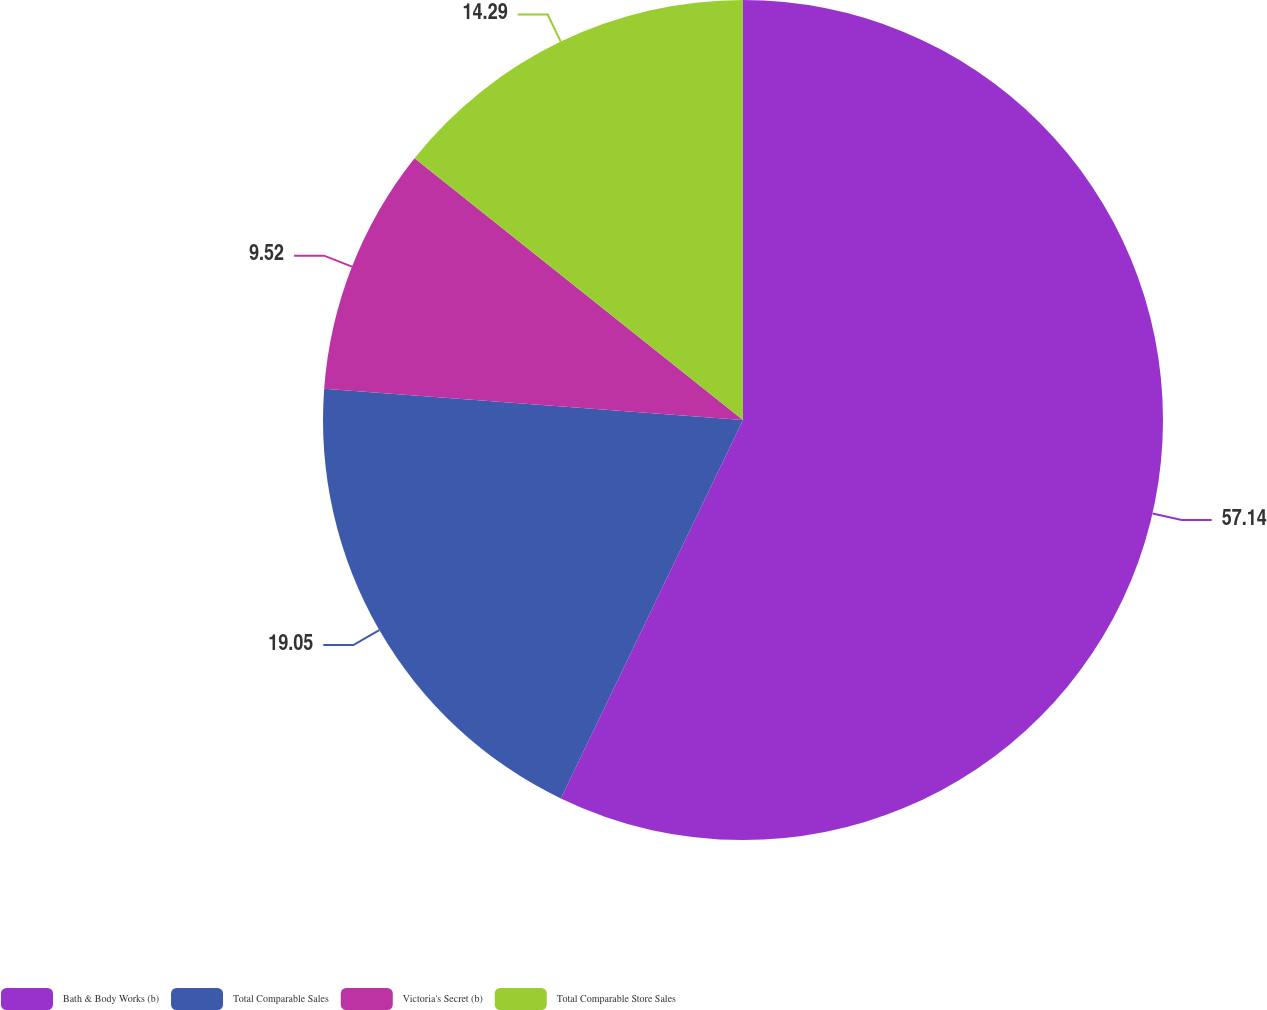Convert chart to OTSL. <chart><loc_0><loc_0><loc_500><loc_500><pie_chart><fcel>Bath & Body Works (b)<fcel>Total Comparable Sales<fcel>Victoria's Secret (b)<fcel>Total Comparable Store Sales<nl><fcel>57.14%<fcel>19.05%<fcel>9.52%<fcel>14.29%<nl></chart> 